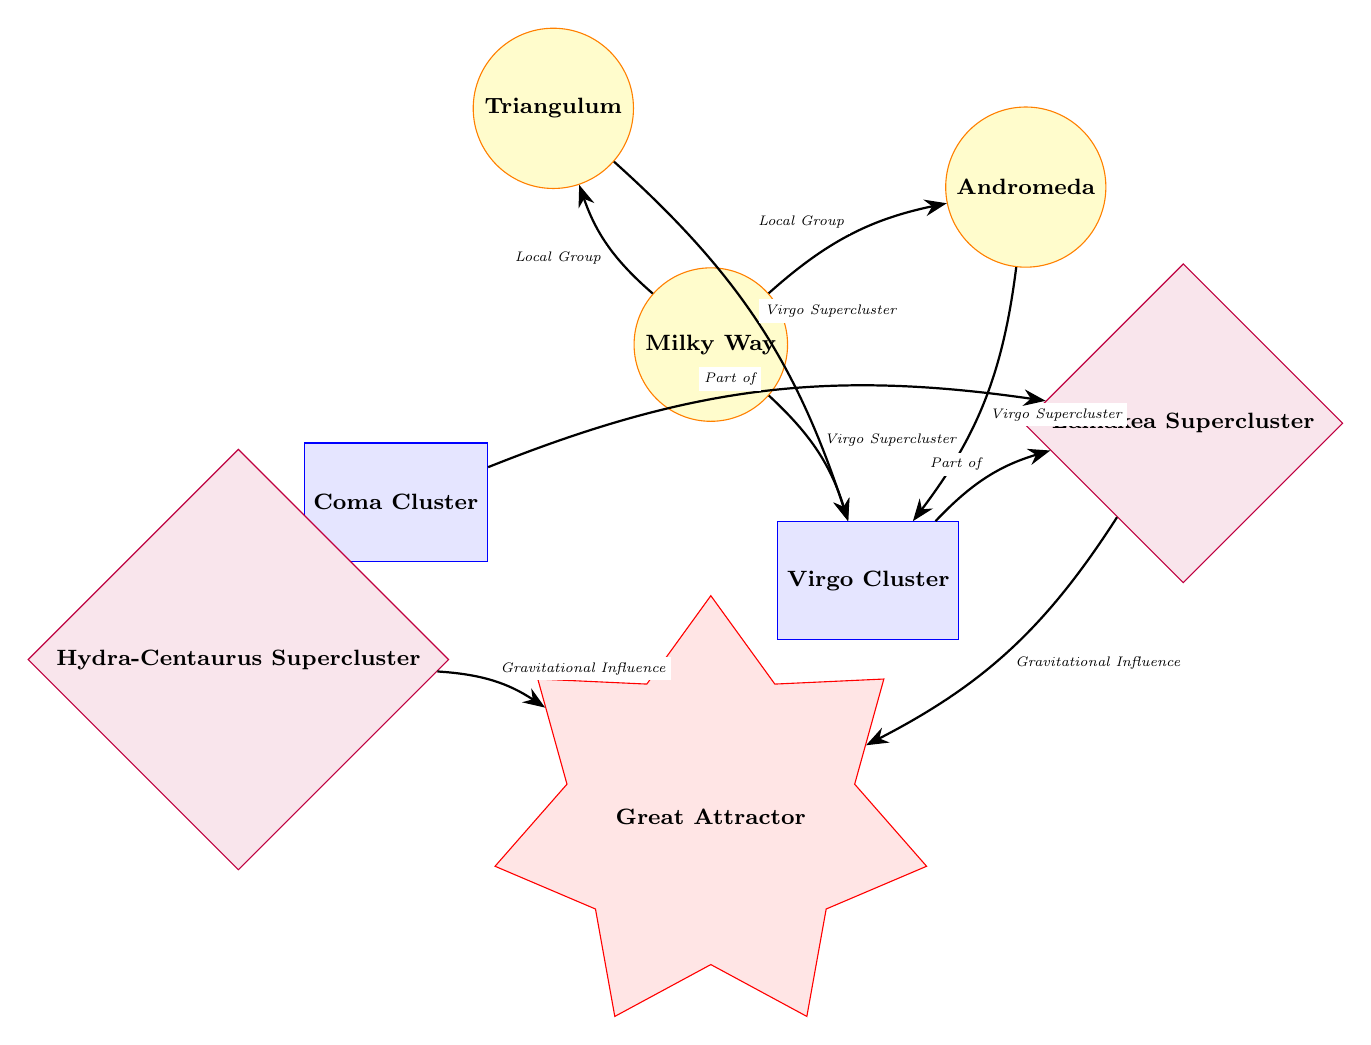What is the central galaxy in the diagram? The diagram shows the Milky Way at the center, surrounded by other galaxies and clusters. Thus, the answer is obtained by identifying the galaxy positioned at the origin point of the diagram.
Answer: Milky Way How many galaxies are depicted in the diagram? By counting the node types labeled "galaxy," two galaxies are present: Milky Way, Andromeda, and Triangulum. Thus, totaling the distinct galaxy nodes reveals the answer.
Answer: 3 Which cluster is connected to the Milky Way? The path labeled "Virgo Supercluster" directly connects the Milky Way to the Virgo Cluster, indicating a relationship. Based on this visual connection, the answer can be derived.
Answer: Virgo Cluster What is the main supercluster featured in the diagram? By identifying the node labeled as "supercluster," Laniakea Supercluster stands out as the main supercluster in the diagram. Hence, the answer is located in this specific node category.
Answer: Laniakea Supercluster How many edges connect to the Virgo Cluster? Counting the number of outgoing edges associated with the Virgo Cluster node indicates that there are connections to the Milky Way, Andromeda, Triangulum, and two additional connections. Performing this count yields the answer.
Answer: 4 Which two structures are influenced by the Great Attractor? The diagram shows gravitational influence lines extending to Laniakea Supercluster and Hydra-Centaurus Supercluster as labeled in the connections leading from the Great Attractor, leading to the reasoning for the answer.
Answer: Laniakea Supercluster, Hydra-Centaurus Supercluster What is the relationship between Andromeda and Virgo Cluster? There is an edge labeled "Virgo Supercluster" that directly connects Andromeda to the Virgo Cluster, indicating a mutual relationship as visualized in the diagram. Thus, the answer is recognized through this connection.
Answer: Virgo Supercluster How many superclusters are represented in the diagram? By identifying and counting the nodes specifically categorized as superclusters in the diagram, we find two: Laniakea Supercluster and Hydra-Centaurus Supercluster, leading to the solution.
Answer: 2 What type of node is the Great Attractor? The node labeled "Great Attractor" is categorized as an attractor shaped like a star, identified by its distinct representation outlined in the legend of the diagram. Hence, the answer can be clearly derived from this classification.
Answer: Attractor 